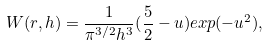<formula> <loc_0><loc_0><loc_500><loc_500>W ( r , h ) = \frac { 1 } { \pi ^ { 3 / 2 } h ^ { 3 } } ( \frac { 5 } { 2 } - u ) e x p ( - u ^ { 2 } ) ,</formula> 